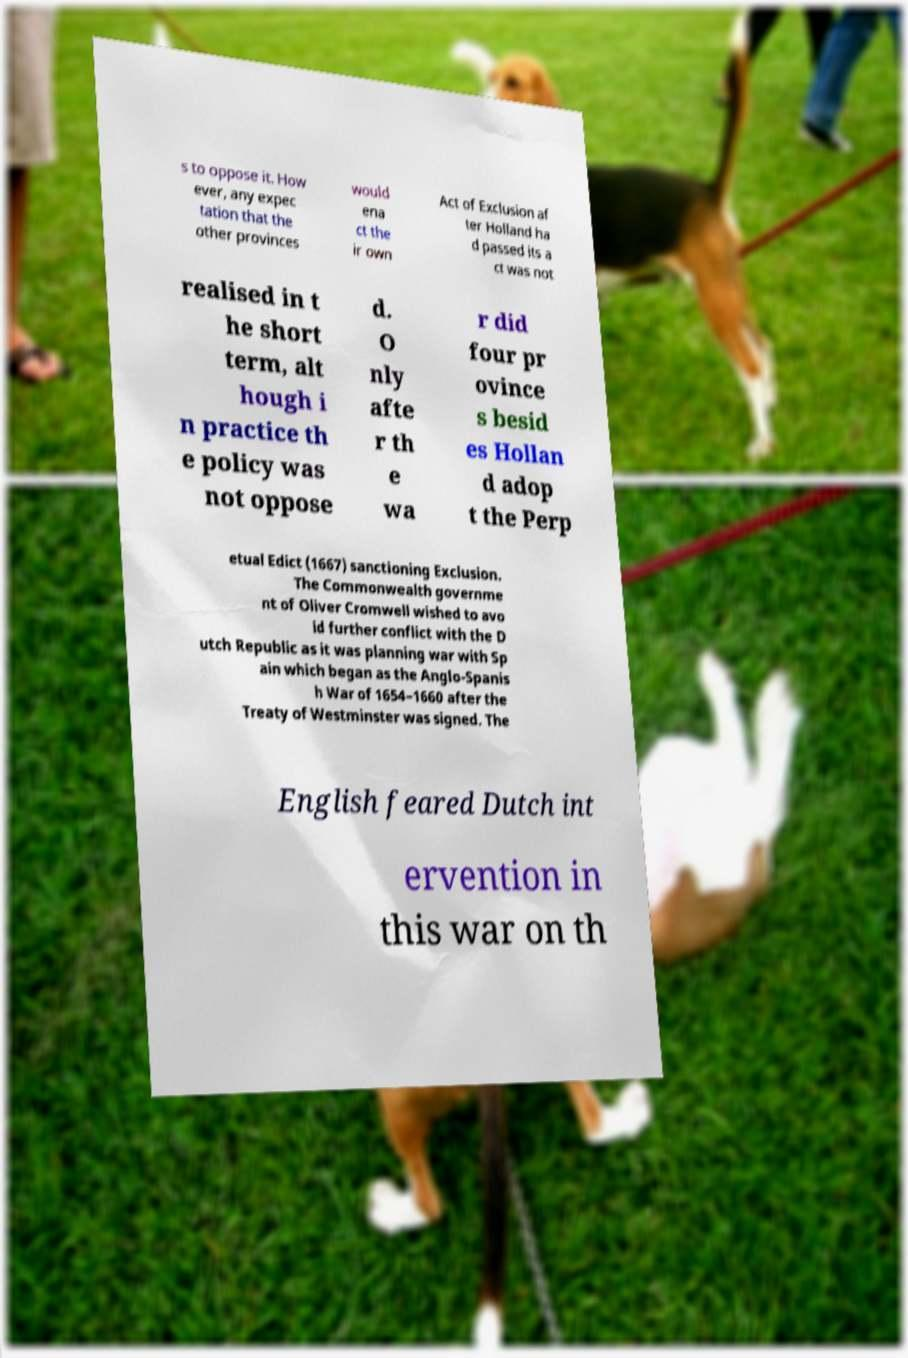I need the written content from this picture converted into text. Can you do that? s to oppose it. How ever, any expec tation that the other provinces would ena ct the ir own Act of Exclusion af ter Holland ha d passed its a ct was not realised in t he short term, alt hough i n practice th e policy was not oppose d. O nly afte r th e wa r did four pr ovince s besid es Hollan d adop t the Perp etual Edict (1667) sanctioning Exclusion. The Commonwealth governme nt of Oliver Cromwell wished to avo id further conflict with the D utch Republic as it was planning war with Sp ain which began as the Anglo-Spanis h War of 1654–1660 after the Treaty of Westminster was signed. The English feared Dutch int ervention in this war on th 